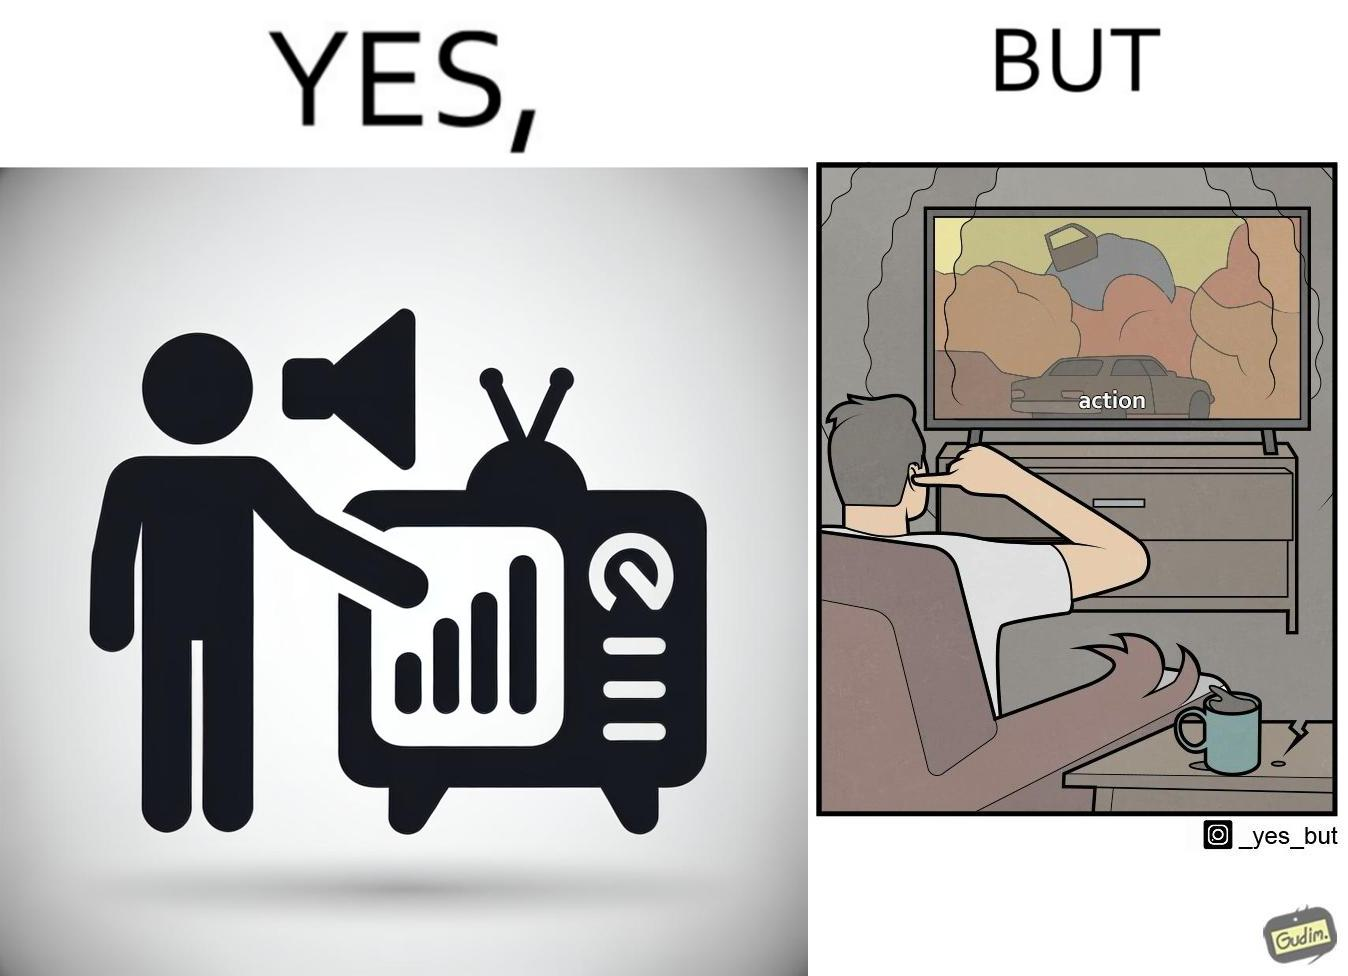Explain why this image is satirical. The action scenes of the movies or TV programs are mostly low in sound and people aren't able to hear them properly but in the action scenes due to the background music and other noise the sound becomes unbearable to some peoples 